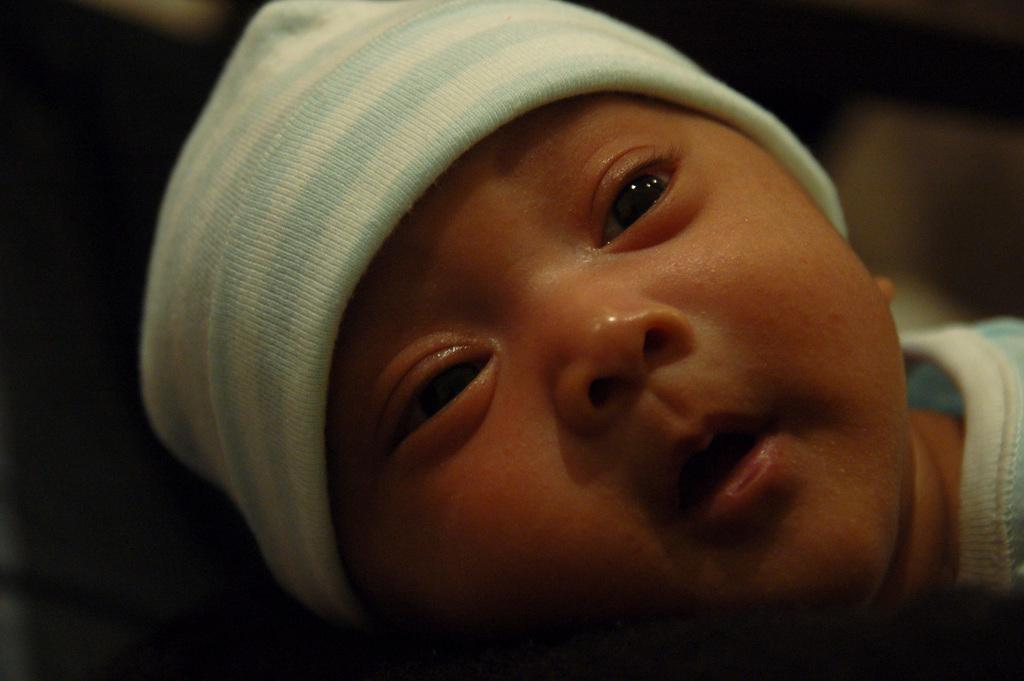What is the main subject of the image? There is a baby in the image. What is the baby wearing on their head? The baby is wearing a blue and white color cap. Can you describe the background of the image? The background of the image is blurred. What type of mark can be seen on the baby's face in the image? There is no mark visible on the baby's face in the image. What kind of popcorn is being served to the baby in the image? There is no popcorn present in the image. 